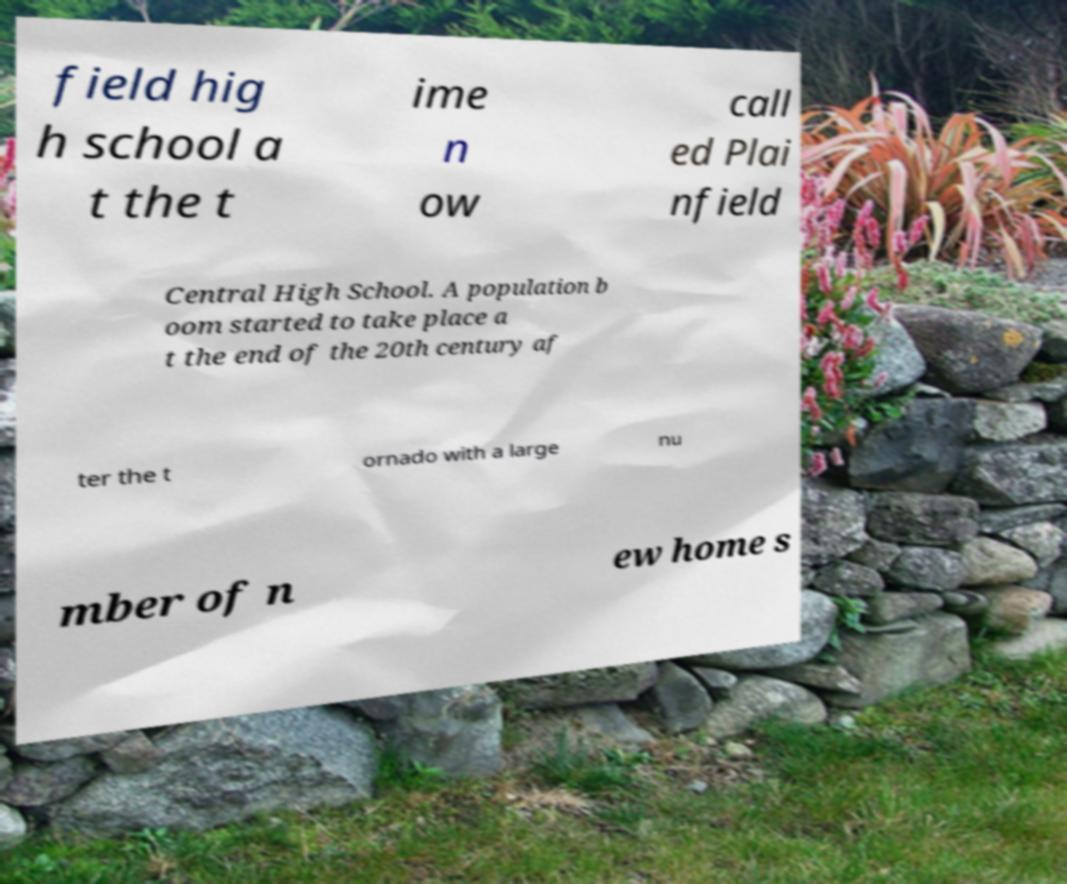Please identify and transcribe the text found in this image. field hig h school a t the t ime n ow call ed Plai nfield Central High School. A population b oom started to take place a t the end of the 20th century af ter the t ornado with a large nu mber of n ew home s 